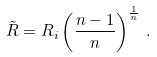Convert formula to latex. <formula><loc_0><loc_0><loc_500><loc_500>\tilde { R } = R _ { i } \left ( \frac { n - 1 } { n } \right ) ^ { \frac { 1 } { n } } \, .</formula> 